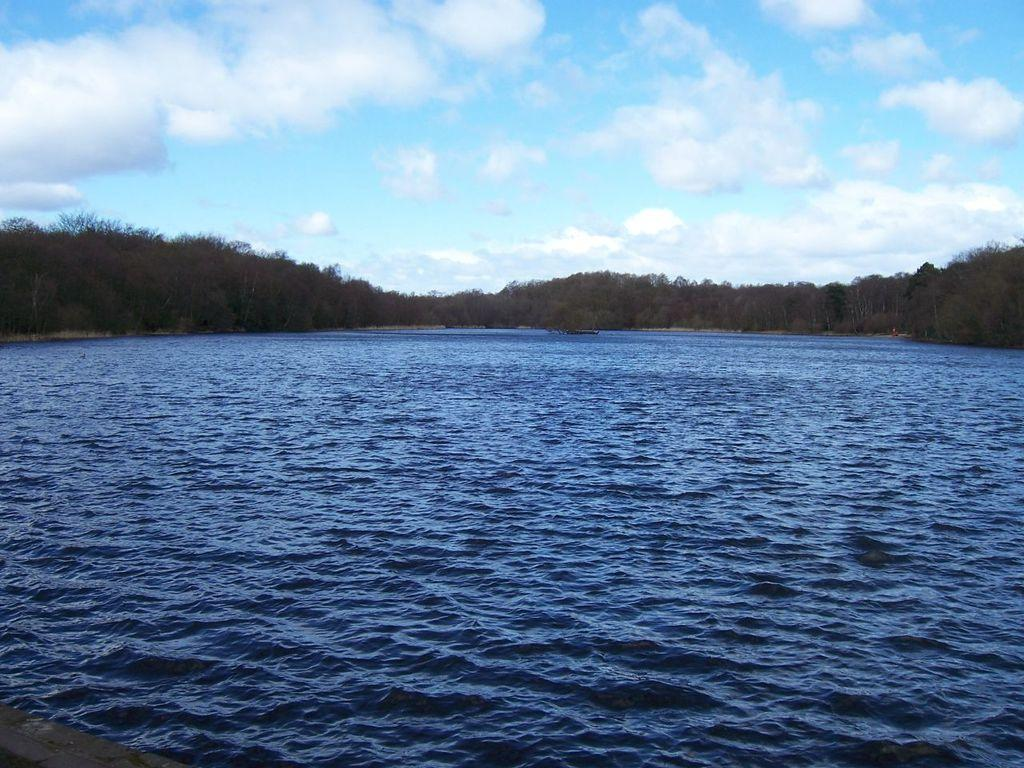What color is the water in the image? The water in the image is blue. What can be seen near the water in the image? There are many trees near the water in the image. What is visible in the background of the image? There are clouds and a blue sky in the background of the image. Where can you find the lettuce growing in the image? There is no lettuce present in the image. What type of soda is being served in the alley in the image? There is no alley or soda present in the image. 